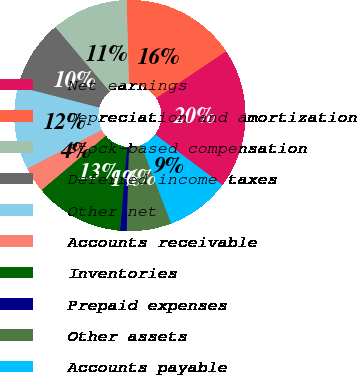<chart> <loc_0><loc_0><loc_500><loc_500><pie_chart><fcel>Net earnings<fcel>Depreciation and amortization<fcel>Stock-based compensation<fcel>Deferred income taxes<fcel>Other net<fcel>Accounts receivable<fcel>Inventories<fcel>Prepaid expenses<fcel>Other assets<fcel>Accounts payable<nl><fcel>19.64%<fcel>16.07%<fcel>10.71%<fcel>9.82%<fcel>11.61%<fcel>3.57%<fcel>12.5%<fcel>0.89%<fcel>6.25%<fcel>8.93%<nl></chart> 